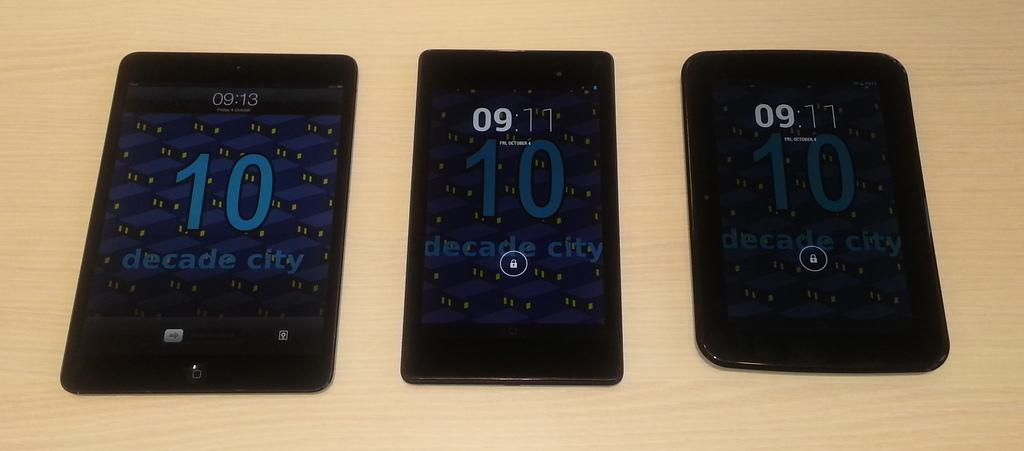<image>
Share a concise interpretation of the image provided. Three phones next to one another with one that says the number 10 on the left. 